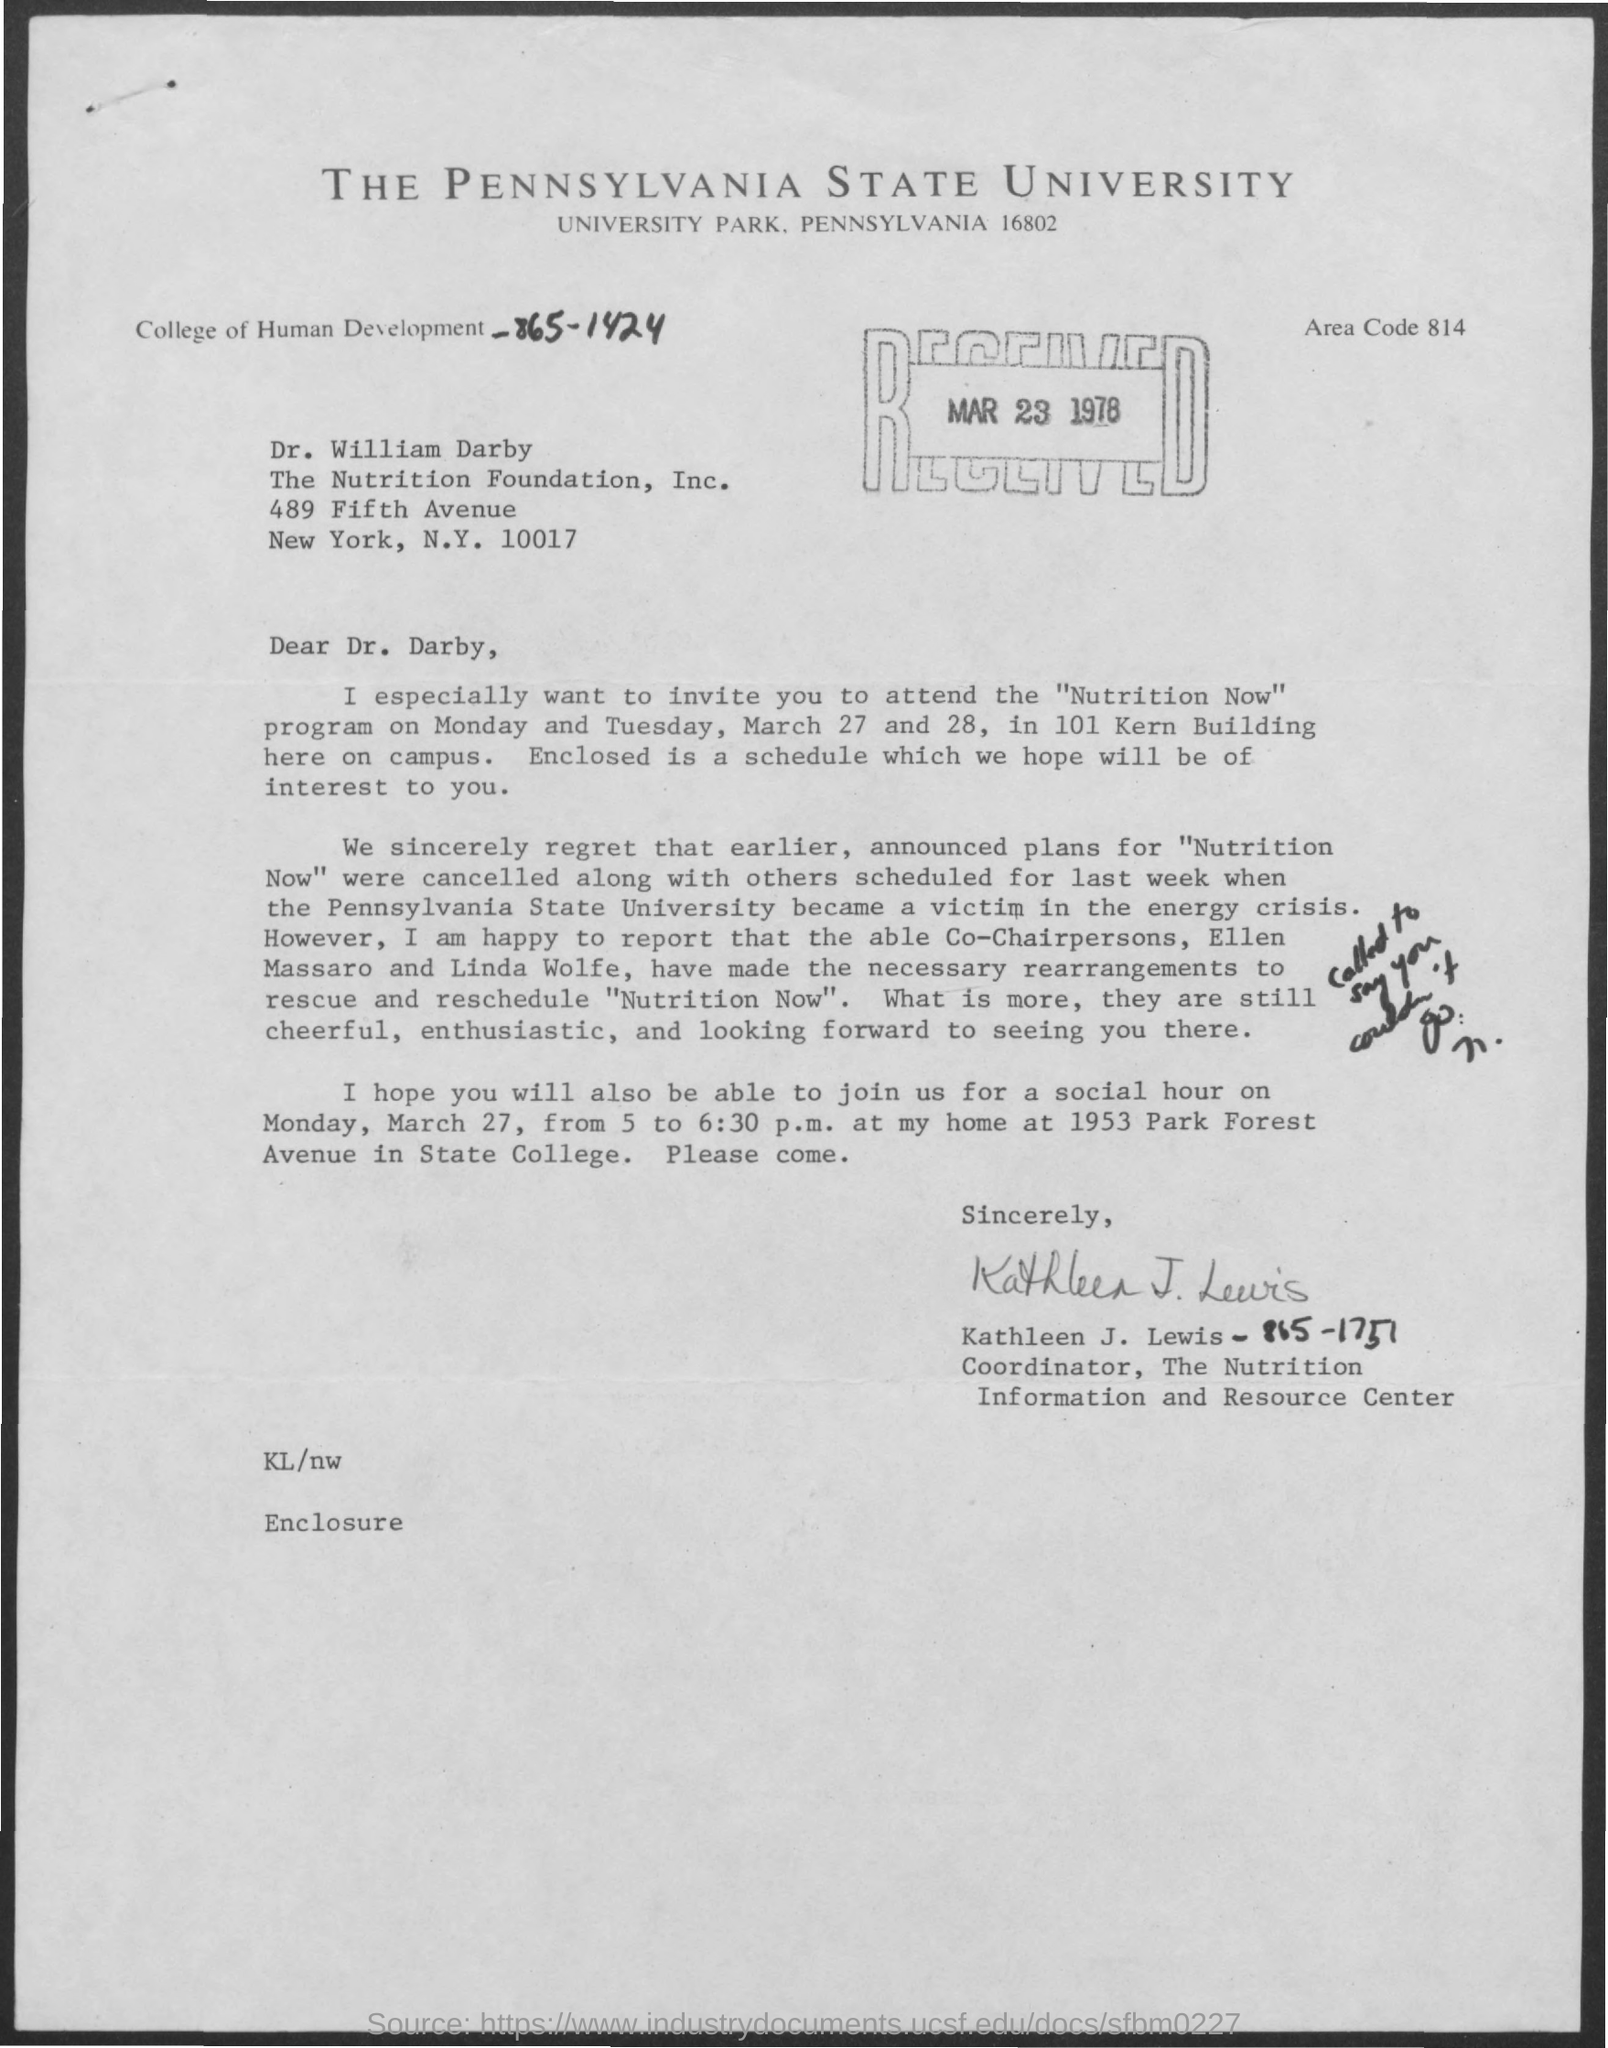Specify some key components in this picture. The program named Nutrition Now was mentioned. The document is dated March 23, 1978. The program will take place on Monday and Tuesday, March 27 and 28. The area code is 814. The letter is addressed to Dr. Darby. 